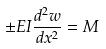Convert formula to latex. <formula><loc_0><loc_0><loc_500><loc_500>\pm E I \frac { d ^ { 2 } w } { d x ^ { 2 } } = M</formula> 